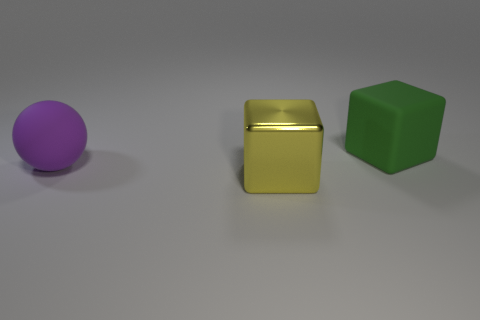What material is the object that is both behind the yellow metallic thing and left of the green block?
Ensure brevity in your answer.  Rubber. There is a big matte object that is to the right of the big purple thing; is it the same shape as the big yellow metal thing?
Offer a very short reply. Yes. Are there fewer green matte cubes than cyan metallic things?
Offer a very short reply. No. Are there more green cubes than large blocks?
Your response must be concise. No. Are the big purple thing and the block that is in front of the matte block made of the same material?
Your response must be concise. No. What number of things are yellow metallic objects or purple rubber balls?
Make the answer very short. 2. How many cylinders are yellow objects or green things?
Your response must be concise. 0. Is there a large green object?
Your answer should be compact. Yes. Are there any other things that are the same shape as the large purple thing?
Keep it short and to the point. No. How many things are objects that are on the right side of the big metal block or big shiny blocks?
Your response must be concise. 2. 